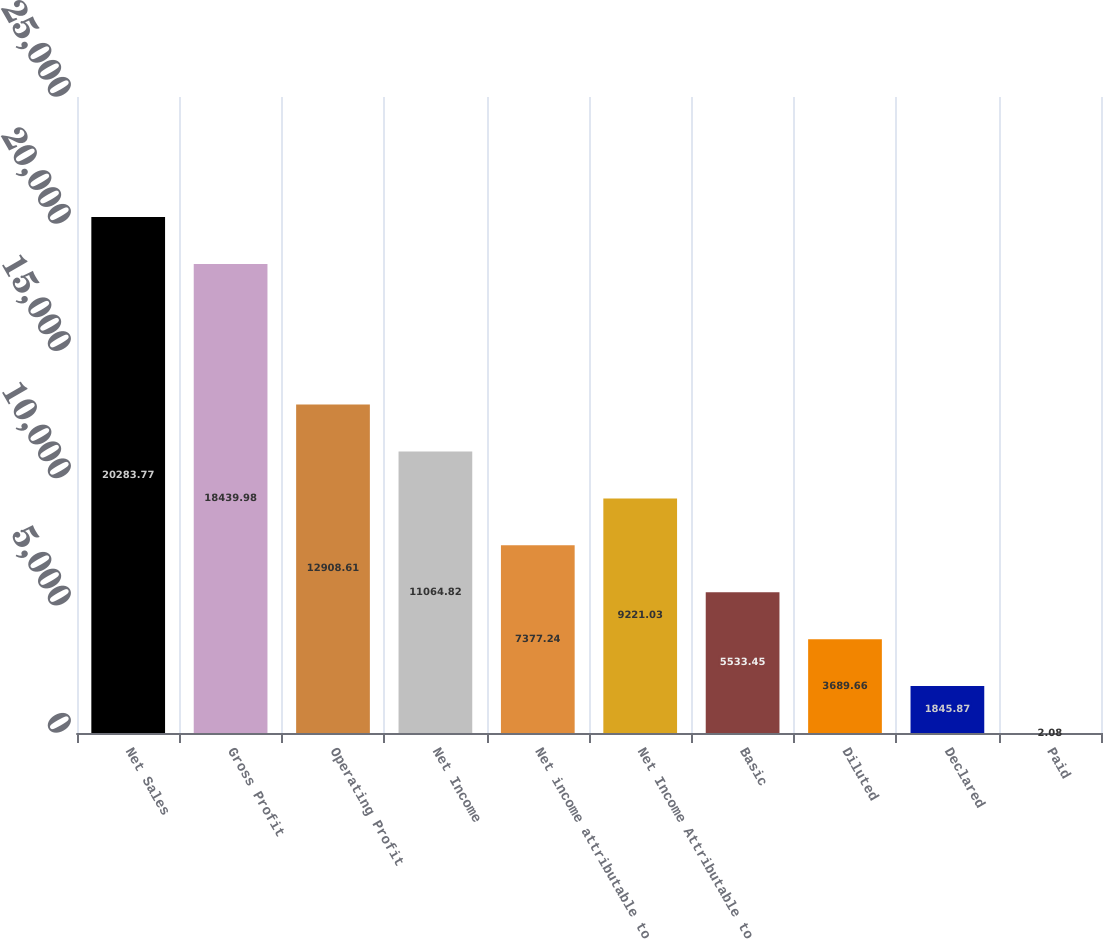Convert chart. <chart><loc_0><loc_0><loc_500><loc_500><bar_chart><fcel>Net Sales<fcel>Gross Profit<fcel>Operating Profit<fcel>Net Income<fcel>Net income attributable to<fcel>Net Income Attributable to<fcel>Basic<fcel>Diluted<fcel>Declared<fcel>Paid<nl><fcel>20283.8<fcel>18440<fcel>12908.6<fcel>11064.8<fcel>7377.24<fcel>9221.03<fcel>5533.45<fcel>3689.66<fcel>1845.87<fcel>2.08<nl></chart> 